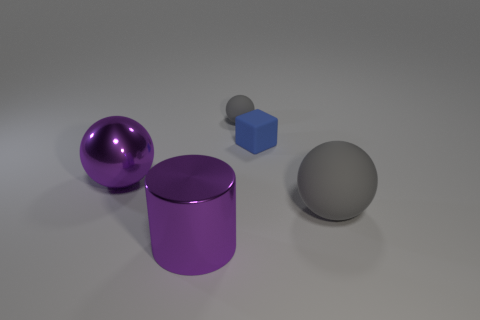Add 2 green balls. How many objects exist? 7 Subtract 0 blue spheres. How many objects are left? 5 Subtract all spheres. How many objects are left? 2 Subtract all big cyan things. Subtract all large metallic balls. How many objects are left? 4 Add 4 tiny gray spheres. How many tiny gray spheres are left? 5 Add 3 rubber blocks. How many rubber blocks exist? 4 